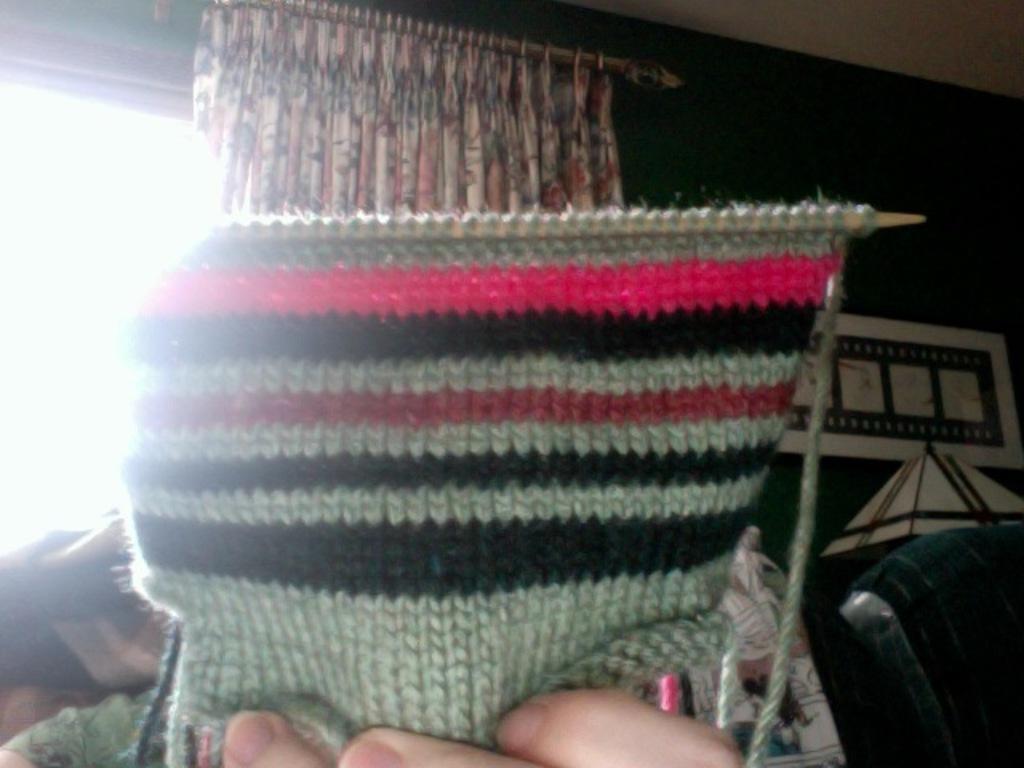How would you summarize this image in a sentence or two? In this image we can see a person knitting wool. In the background there are curtain to the window, table lap and a wall hanging attached to the wall. 